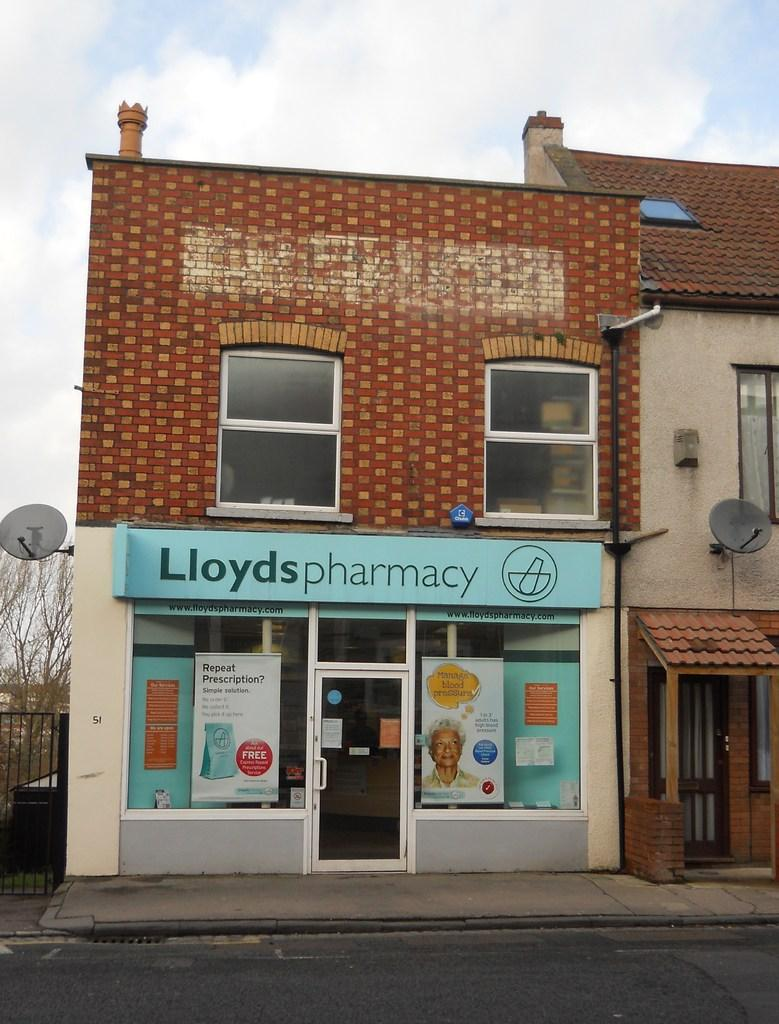What is the main structure in the center of the image? There is a building in the center of the image. What is located at the bottom of the image? There is a road at the bottom of the image. What can be seen on the left side of the image? There is a gate and a tree on the left side of the image. What is visible in the background of the image? The sky is visible in the background of the image. What type of creature can be seen holding onto the gate in the image? There is no creature present in the image; it only features a building, road, gate, tree, and sky. 